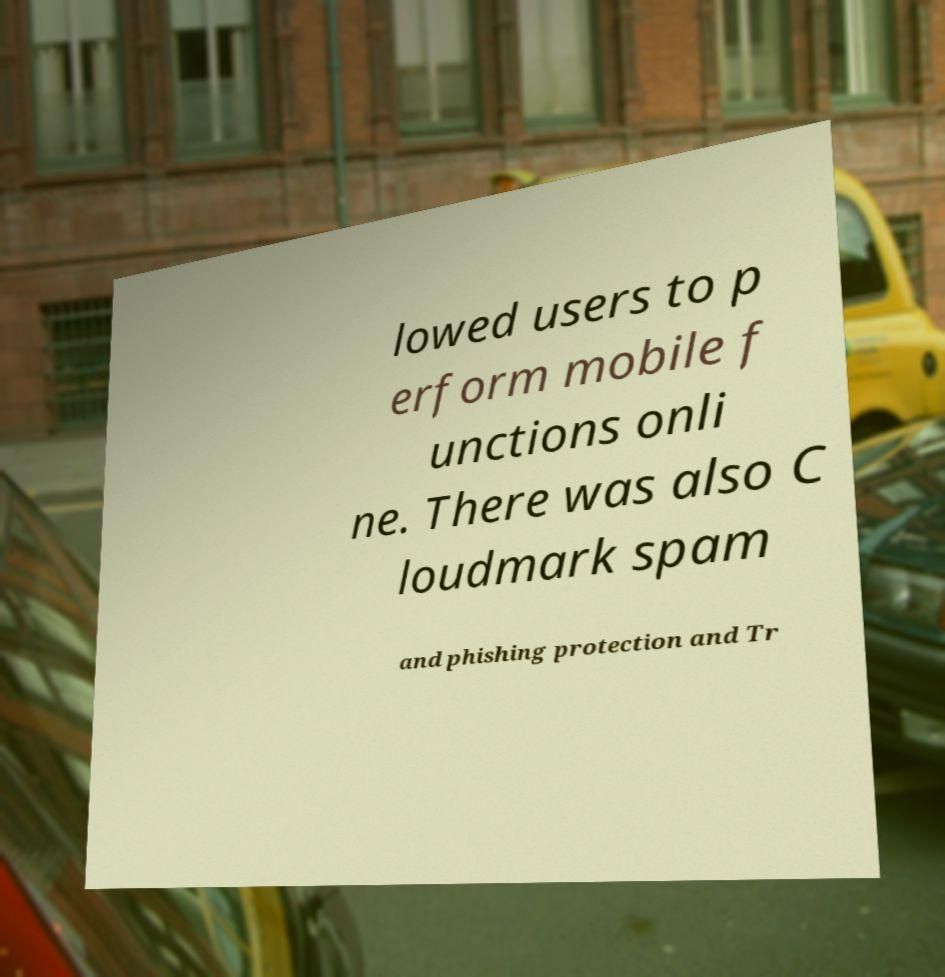Can you read and provide the text displayed in the image?This photo seems to have some interesting text. Can you extract and type it out for me? lowed users to p erform mobile f unctions onli ne. There was also C loudmark spam and phishing protection and Tr 